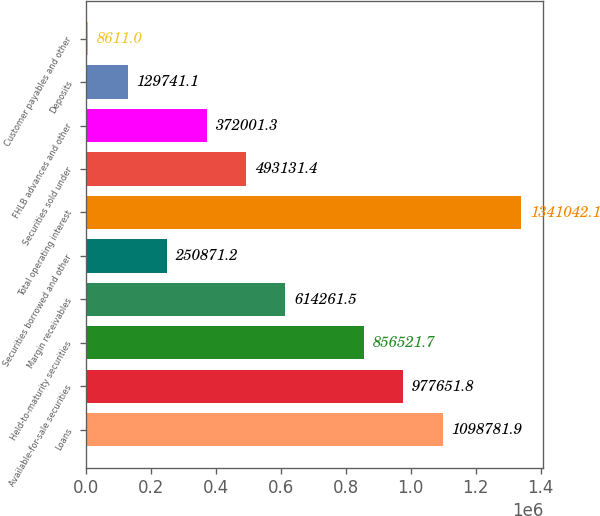Convert chart to OTSL. <chart><loc_0><loc_0><loc_500><loc_500><bar_chart><fcel>Loans<fcel>Available-for-sale securities<fcel>Held-to-maturity securities<fcel>Margin receivables<fcel>Securities borrowed and other<fcel>Total operating interest<fcel>Securities sold under<fcel>FHLB advances and other<fcel>Deposits<fcel>Customer payables and other<nl><fcel>1.09878e+06<fcel>977652<fcel>856522<fcel>614262<fcel>250871<fcel>1.34104e+06<fcel>493131<fcel>372001<fcel>129741<fcel>8611<nl></chart> 